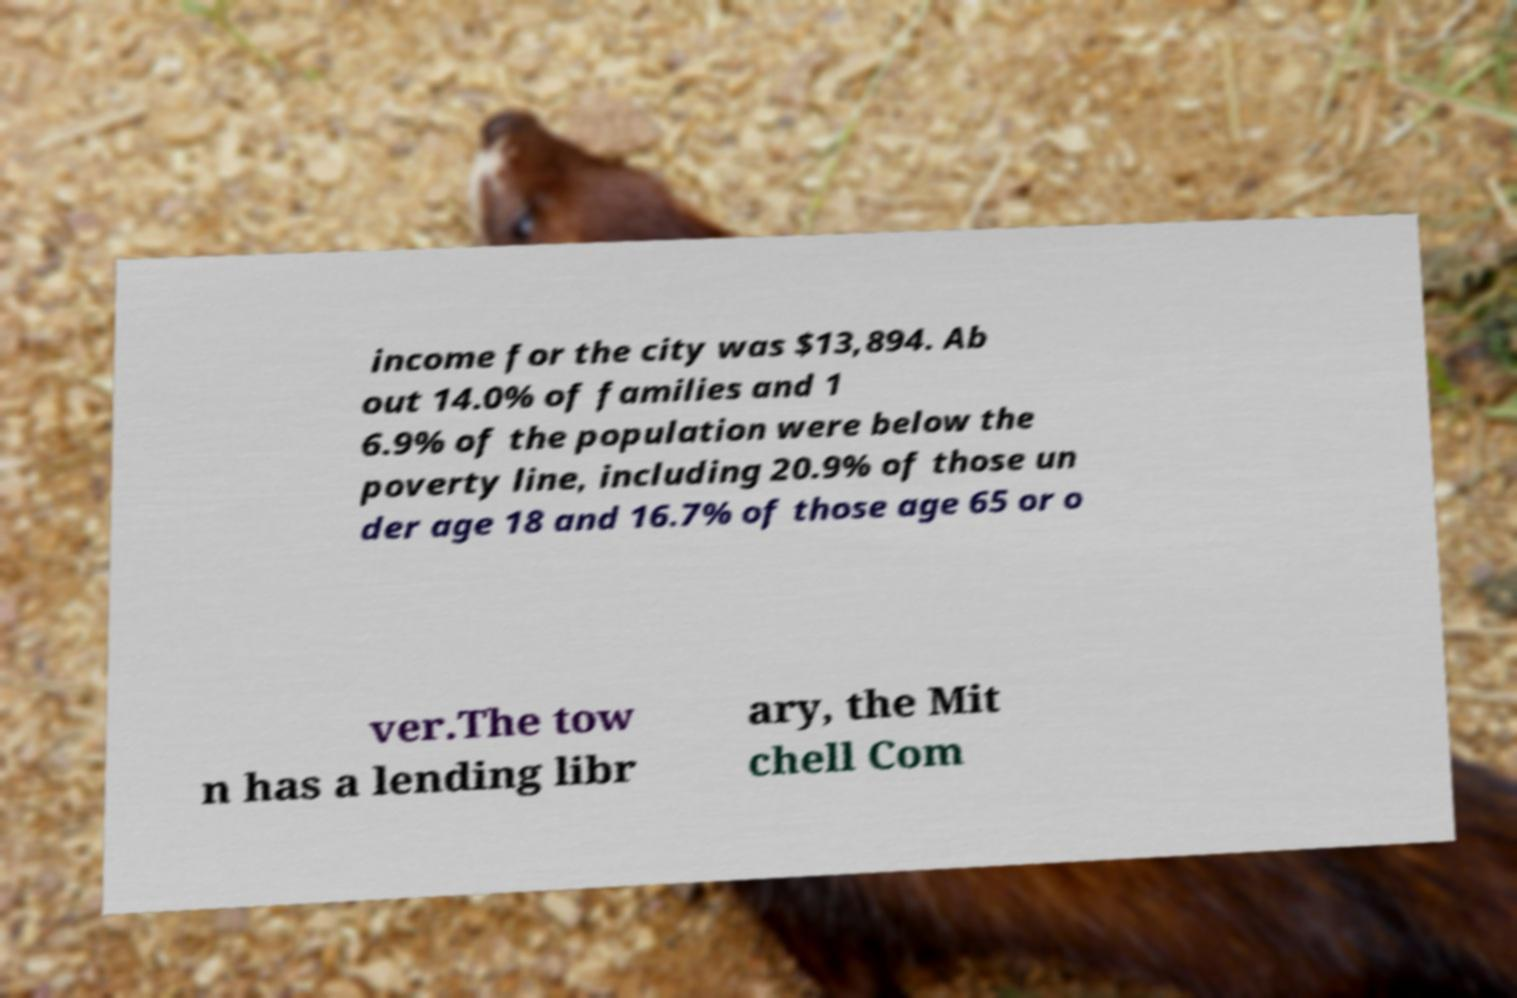Please identify and transcribe the text found in this image. income for the city was $13,894. Ab out 14.0% of families and 1 6.9% of the population were below the poverty line, including 20.9% of those un der age 18 and 16.7% of those age 65 or o ver.The tow n has a lending libr ary, the Mit chell Com 